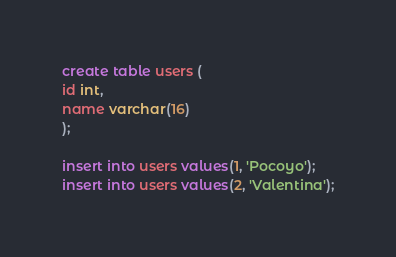<code> <loc_0><loc_0><loc_500><loc_500><_SQL_>
create table users (
id int,
name varchar(16)
);

insert into users values(1, 'Pocoyo');
insert into users values(2, 'Valentina');
</code> 